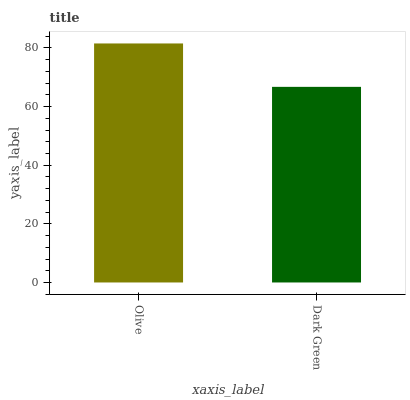Is Dark Green the minimum?
Answer yes or no. Yes. Is Olive the maximum?
Answer yes or no. Yes. Is Dark Green the maximum?
Answer yes or no. No. Is Olive greater than Dark Green?
Answer yes or no. Yes. Is Dark Green less than Olive?
Answer yes or no. Yes. Is Dark Green greater than Olive?
Answer yes or no. No. Is Olive less than Dark Green?
Answer yes or no. No. Is Olive the high median?
Answer yes or no. Yes. Is Dark Green the low median?
Answer yes or no. Yes. Is Dark Green the high median?
Answer yes or no. No. Is Olive the low median?
Answer yes or no. No. 